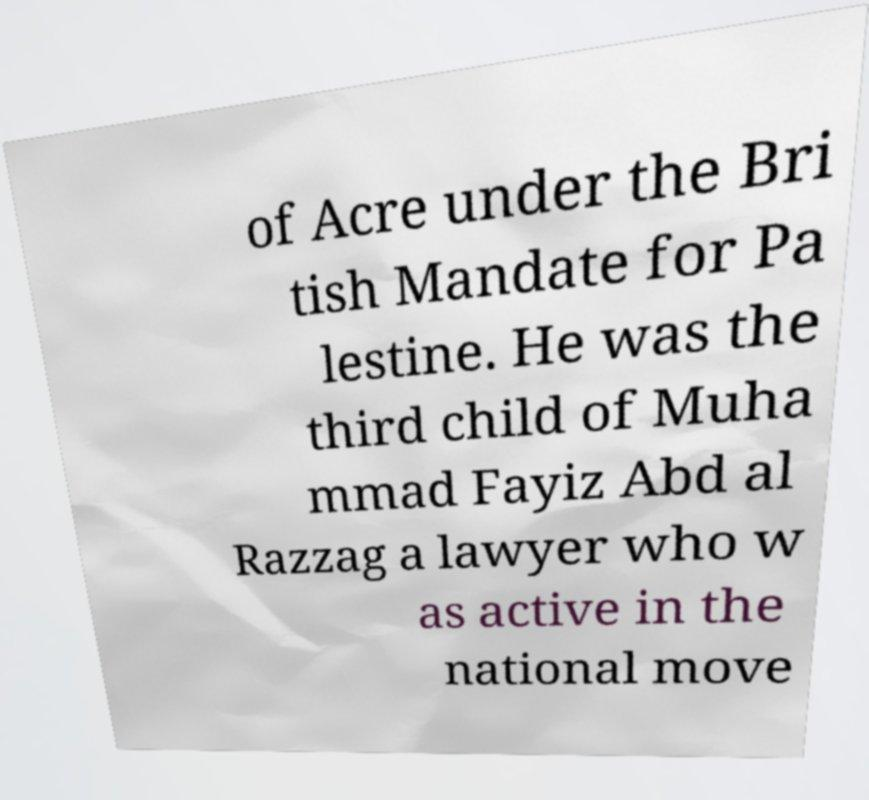Could you extract and type out the text from this image? of Acre under the Bri tish Mandate for Pa lestine. He was the third child of Muha mmad Fayiz Abd al Razzag a lawyer who w as active in the national move 